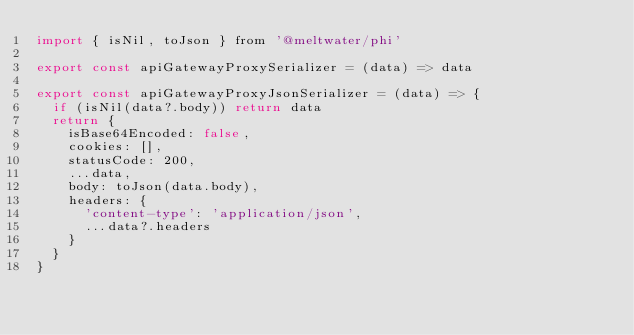<code> <loc_0><loc_0><loc_500><loc_500><_JavaScript_>import { isNil, toJson } from '@meltwater/phi'

export const apiGatewayProxySerializer = (data) => data

export const apiGatewayProxyJsonSerializer = (data) => {
  if (isNil(data?.body)) return data
  return {
    isBase64Encoded: false,
    cookies: [],
    statusCode: 200,
    ...data,
    body: toJson(data.body),
    headers: {
      'content-type': 'application/json',
      ...data?.headers
    }
  }
}
</code> 